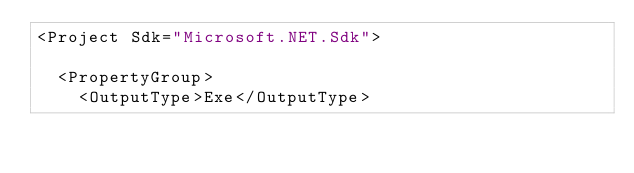<code> <loc_0><loc_0><loc_500><loc_500><_XML_><Project Sdk="Microsoft.NET.Sdk">

  <PropertyGroup>
    <OutputType>Exe</OutputType></code> 